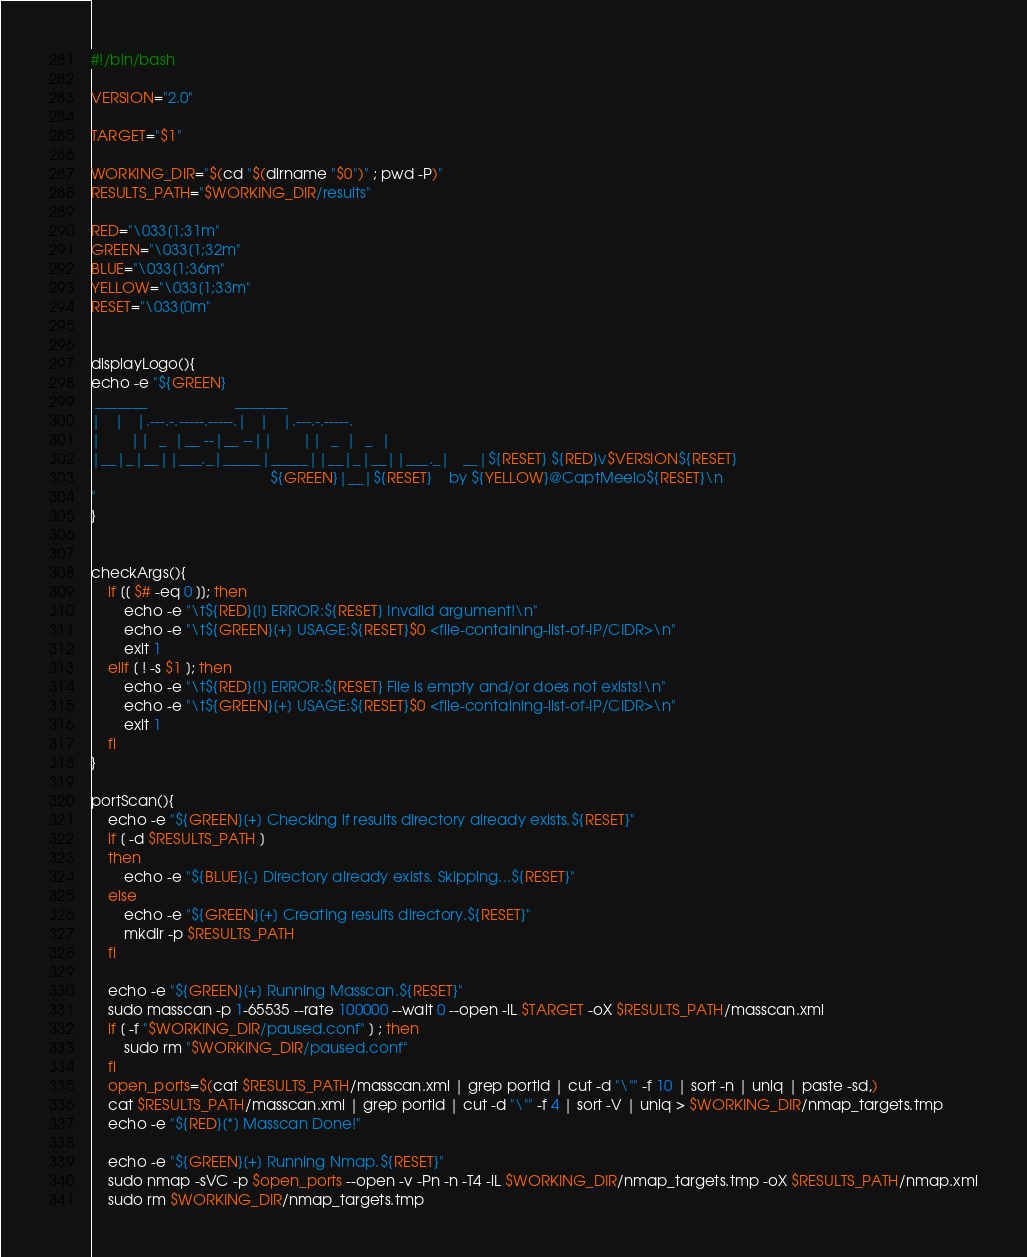Convert code to text. <code><loc_0><loc_0><loc_500><loc_500><_Bash_>#!/bin/bash

VERSION="2.0"

TARGET="$1"

WORKING_DIR="$(cd "$(dirname "$0")" ; pwd -P)"
RESULTS_PATH="$WORKING_DIR/results"

RED="\033[1;31m"
GREEN="\033[1;32m"
BLUE="\033[1;36m"
YELLOW="\033[1;33m"
RESET="\033[0m"


displayLogo(){
echo -e "${GREEN}                               
 _______                     _______              
|   |   |.---.-.-----.-----.|   |   |.---.-.-----.
|       ||  _  |__ --|__ --||       ||  _  |  _  |
|__|_|__||___._|_____|_____||__|_|__||___._|   __|${RESET} ${RED}v$VERSION${RESET}  
                                           ${GREEN}|__|${RESET}    by ${YELLOW}@CaptMeelo${RESET}\n
"
}


checkArgs(){
    if [[ $# -eq 0 ]]; then
        echo -e "\t${RED}[!] ERROR:${RESET} Invalid argument!\n"
        echo -e "\t${GREEN}[+] USAGE:${RESET}$0 <file-containing-list-of-IP/CIDR>\n"
        exit 1
    elif [ ! -s $1 ]; then
        echo -e "\t${RED}[!] ERROR:${RESET} File is empty and/or does not exists!\n"
        echo -e "\t${GREEN}[+] USAGE:${RESET}$0 <file-containing-list-of-IP/CIDR>\n"
        exit 1
    fi
}

portScan(){
    echo -e "${GREEN}[+] Checking if results directory already exists.${RESET}"
    if [ -d $RESULTS_PATH ]
    then
        echo -e "${BLUE}[-] Directory already exists. Skipping...${RESET}"
    else
        echo -e "${GREEN}[+] Creating results directory.${RESET}"
        mkdir -p $RESULTS_PATH
    fi

    echo -e "${GREEN}[+] Running Masscan.${RESET}"
    sudo masscan -p 1-65535 --rate 100000 --wait 0 --open -iL $TARGET -oX $RESULTS_PATH/masscan.xml
    if [ -f "$WORKING_DIR/paused.conf" ] ; then
        sudo rm "$WORKING_DIR/paused.conf"
    fi
    open_ports=$(cat $RESULTS_PATH/masscan.xml | grep portid | cut -d "\"" -f 10 | sort -n | uniq | paste -sd,)
    cat $RESULTS_PATH/masscan.xml | grep portid | cut -d "\"" -f 4 | sort -V | uniq > $WORKING_DIR/nmap_targets.tmp
    echo -e "${RED}[*] Masscan Done!"

    echo -e "${GREEN}[+] Running Nmap.${RESET}"
    sudo nmap -sVC -p $open_ports --open -v -Pn -n -T4 -iL $WORKING_DIR/nmap_targets.tmp -oX $RESULTS_PATH/nmap.xml
    sudo rm $WORKING_DIR/nmap_targets.tmp</code> 